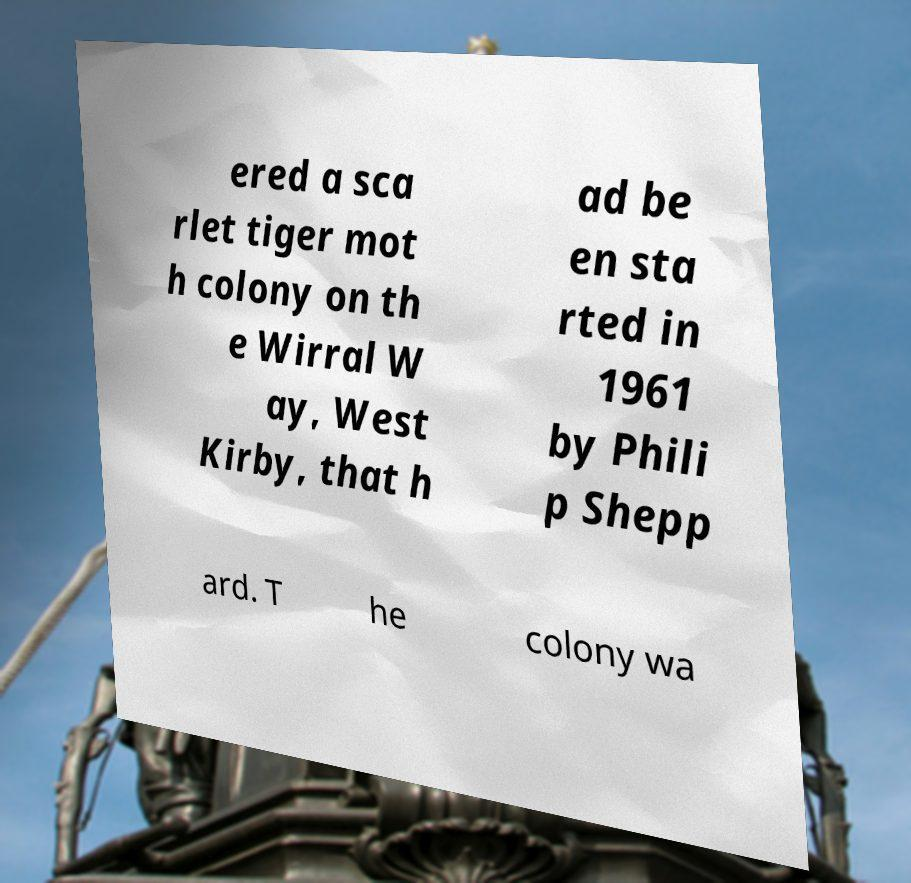Could you assist in decoding the text presented in this image and type it out clearly? ered a sca rlet tiger mot h colony on th e Wirral W ay, West Kirby, that h ad be en sta rted in 1961 by Phili p Shepp ard. T he colony wa 